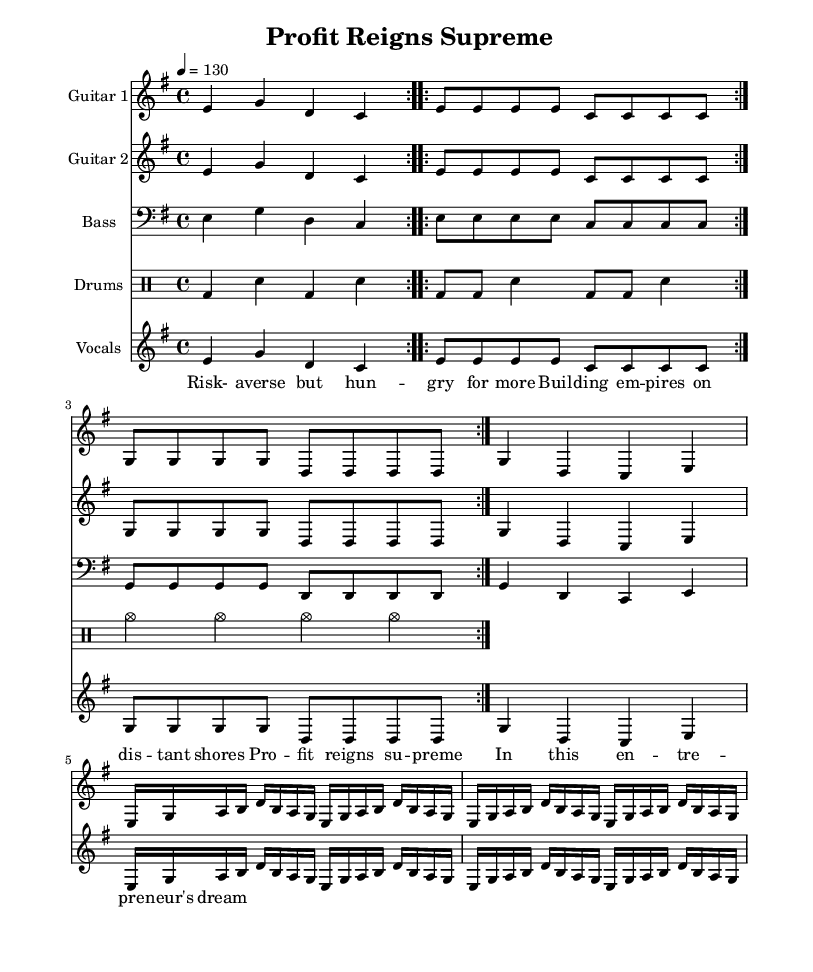What is the key signature of this music? The key signature is indicated at the beginning of the score. It shows one sharp, which corresponds to E minor.
Answer: E minor What is the time signature of this music? The time signature appears at the beginning of the sheet music and shows how many beats are in a measure. Here, 4/4 means four beats per measure.
Answer: 4/4 What is the tempo marking in beats per minute? The tempo is indicated in the score as "4 = 130", meaning there are 130 beats per minute.
Answer: 130 How many measures are in the vocal part section? By counting the segments in the vocal section, we can see that it consists of four measures. Each line has specific lyrics corresponding to the music notes.
Answer: 4 What is the primary theme of the lyrics? By reading through the lyrics provided, the theme revolves around ambition in business while maintaining a risk-averse approach towards entrepreneurship.
Answer: Business success What instruments are featured in this arrangement? The score lists multiple instruments at the beginning: Guitar 1, Guitar 2, Bass, Drums, and Vocals. All enhance the heavy metal sound.
Answer: Guitar 1, Guitar 2, Bass, Drums, Vocals What rhythmic patterns are used in the drums part? The drum score includes bass drum (bd) and snare (sn) patterns which alternate, emphasizing the driving rhythm typical in metal music. The repeated rhythms create a solid foundation for the song.
Answer: Alternating bass and snare patterns 